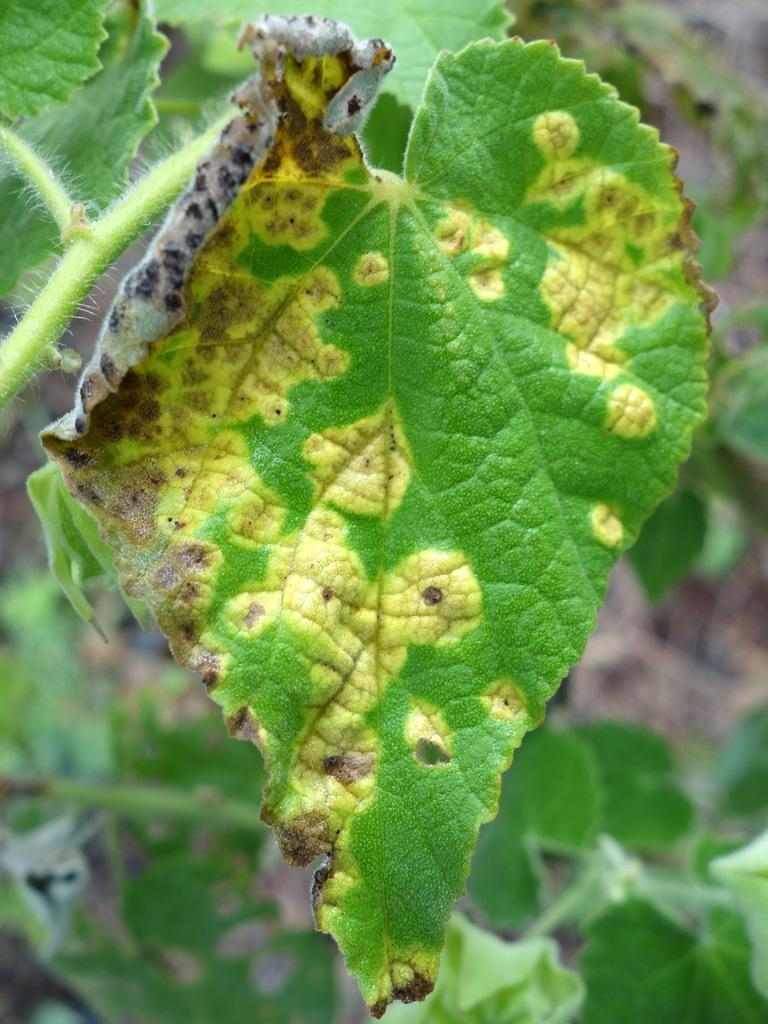What can be observed about the background of the image? The background portion of the picture is blurred. What type of plant elements are present in the image? There are leaves and stems in the image. What word is written on the wrist of the person in the image? There is no person present in the image, and therefore no wrist or word can be observed. 